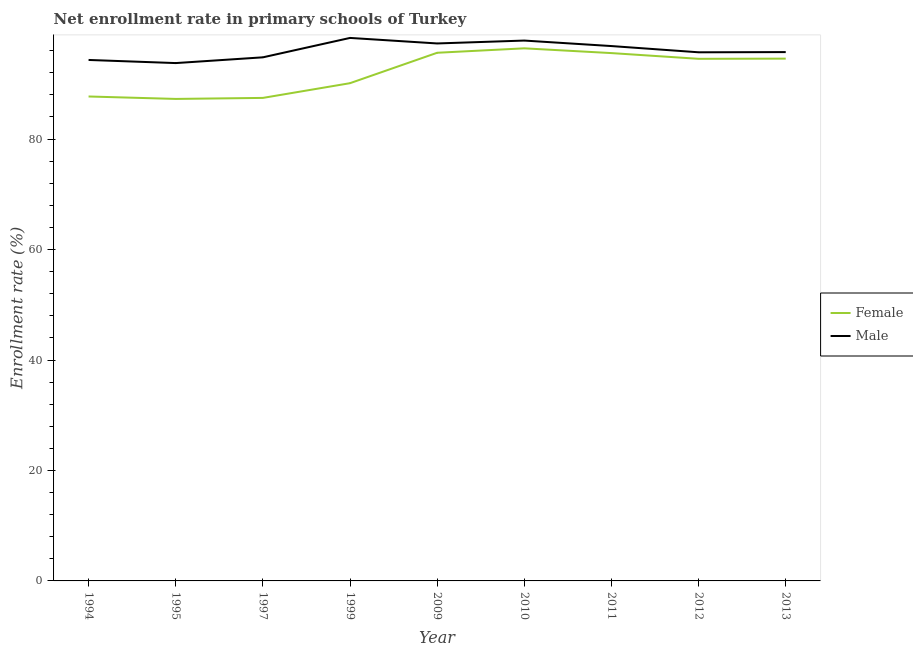Is the number of lines equal to the number of legend labels?
Your response must be concise. Yes. What is the enrollment rate of female students in 1997?
Offer a terse response. 87.46. Across all years, what is the maximum enrollment rate of male students?
Offer a terse response. 98.32. Across all years, what is the minimum enrollment rate of female students?
Provide a short and direct response. 87.27. In which year was the enrollment rate of female students minimum?
Give a very brief answer. 1995. What is the total enrollment rate of female students in the graph?
Offer a very short reply. 829.29. What is the difference between the enrollment rate of male students in 1994 and that in 2009?
Offer a very short reply. -2.99. What is the difference between the enrollment rate of male students in 2009 and the enrollment rate of female students in 1997?
Offer a very short reply. 9.86. What is the average enrollment rate of male students per year?
Your answer should be compact. 96.07. In the year 1997, what is the difference between the enrollment rate of male students and enrollment rate of female students?
Give a very brief answer. 7.35. In how many years, is the enrollment rate of female students greater than 52 %?
Your answer should be very brief. 9. What is the ratio of the enrollment rate of male students in 2010 to that in 2013?
Offer a terse response. 1.02. Is the difference between the enrollment rate of female students in 1995 and 1997 greater than the difference between the enrollment rate of male students in 1995 and 1997?
Your answer should be compact. Yes. What is the difference between the highest and the second highest enrollment rate of female students?
Your answer should be very brief. 0.8. What is the difference between the highest and the lowest enrollment rate of male students?
Ensure brevity in your answer.  4.56. In how many years, is the enrollment rate of male students greater than the average enrollment rate of male students taken over all years?
Your answer should be compact. 4. Is the sum of the enrollment rate of male students in 1994 and 2009 greater than the maximum enrollment rate of female students across all years?
Offer a very short reply. Yes. Is the enrollment rate of female students strictly less than the enrollment rate of male students over the years?
Your answer should be very brief. Yes. How many years are there in the graph?
Give a very brief answer. 9. What is the difference between two consecutive major ticks on the Y-axis?
Ensure brevity in your answer.  20. Are the values on the major ticks of Y-axis written in scientific E-notation?
Give a very brief answer. No. Does the graph contain any zero values?
Your answer should be very brief. No. Does the graph contain grids?
Provide a short and direct response. No. Where does the legend appear in the graph?
Your answer should be compact. Center right. How many legend labels are there?
Provide a succinct answer. 2. What is the title of the graph?
Provide a short and direct response. Net enrollment rate in primary schools of Turkey. Does "From Government" appear as one of the legend labels in the graph?
Provide a succinct answer. No. What is the label or title of the X-axis?
Your response must be concise. Year. What is the label or title of the Y-axis?
Provide a succinct answer. Enrollment rate (%). What is the Enrollment rate (%) in Female in 1994?
Provide a short and direct response. 87.71. What is the Enrollment rate (%) in Male in 1994?
Your response must be concise. 94.33. What is the Enrollment rate (%) in Female in 1995?
Give a very brief answer. 87.27. What is the Enrollment rate (%) in Male in 1995?
Provide a succinct answer. 93.76. What is the Enrollment rate (%) in Female in 1997?
Provide a succinct answer. 87.46. What is the Enrollment rate (%) of Male in 1997?
Provide a short and direct response. 94.8. What is the Enrollment rate (%) in Female in 1999?
Keep it short and to the point. 90.12. What is the Enrollment rate (%) of Male in 1999?
Make the answer very short. 98.32. What is the Enrollment rate (%) of Female in 2009?
Your response must be concise. 95.63. What is the Enrollment rate (%) in Male in 2009?
Your answer should be very brief. 97.31. What is the Enrollment rate (%) of Female in 2010?
Ensure brevity in your answer.  96.43. What is the Enrollment rate (%) in Male in 2010?
Offer a terse response. 97.84. What is the Enrollment rate (%) in Female in 2011?
Make the answer very short. 95.57. What is the Enrollment rate (%) in Male in 2011?
Your response must be concise. 96.84. What is the Enrollment rate (%) of Female in 2012?
Provide a short and direct response. 94.53. What is the Enrollment rate (%) of Male in 2012?
Provide a succinct answer. 95.71. What is the Enrollment rate (%) in Female in 2013?
Ensure brevity in your answer.  94.57. What is the Enrollment rate (%) of Male in 2013?
Your answer should be very brief. 95.75. Across all years, what is the maximum Enrollment rate (%) in Female?
Offer a terse response. 96.43. Across all years, what is the maximum Enrollment rate (%) of Male?
Your response must be concise. 98.32. Across all years, what is the minimum Enrollment rate (%) of Female?
Your answer should be compact. 87.27. Across all years, what is the minimum Enrollment rate (%) in Male?
Your answer should be compact. 93.76. What is the total Enrollment rate (%) of Female in the graph?
Your response must be concise. 829.29. What is the total Enrollment rate (%) of Male in the graph?
Provide a short and direct response. 864.66. What is the difference between the Enrollment rate (%) in Female in 1994 and that in 1995?
Offer a very short reply. 0.44. What is the difference between the Enrollment rate (%) in Male in 1994 and that in 1995?
Offer a very short reply. 0.57. What is the difference between the Enrollment rate (%) in Female in 1994 and that in 1997?
Your answer should be compact. 0.26. What is the difference between the Enrollment rate (%) in Male in 1994 and that in 1997?
Keep it short and to the point. -0.48. What is the difference between the Enrollment rate (%) of Female in 1994 and that in 1999?
Your answer should be very brief. -2.41. What is the difference between the Enrollment rate (%) in Male in 1994 and that in 1999?
Keep it short and to the point. -3.99. What is the difference between the Enrollment rate (%) of Female in 1994 and that in 2009?
Make the answer very short. -7.91. What is the difference between the Enrollment rate (%) in Male in 1994 and that in 2009?
Your response must be concise. -2.99. What is the difference between the Enrollment rate (%) in Female in 1994 and that in 2010?
Offer a terse response. -8.72. What is the difference between the Enrollment rate (%) in Male in 1994 and that in 2010?
Your answer should be compact. -3.51. What is the difference between the Enrollment rate (%) in Female in 1994 and that in 2011?
Provide a succinct answer. -7.86. What is the difference between the Enrollment rate (%) of Male in 1994 and that in 2011?
Provide a succinct answer. -2.52. What is the difference between the Enrollment rate (%) of Female in 1994 and that in 2012?
Keep it short and to the point. -6.82. What is the difference between the Enrollment rate (%) of Male in 1994 and that in 2012?
Your response must be concise. -1.39. What is the difference between the Enrollment rate (%) in Female in 1994 and that in 2013?
Keep it short and to the point. -6.85. What is the difference between the Enrollment rate (%) in Male in 1994 and that in 2013?
Keep it short and to the point. -1.42. What is the difference between the Enrollment rate (%) in Female in 1995 and that in 1997?
Keep it short and to the point. -0.18. What is the difference between the Enrollment rate (%) of Male in 1995 and that in 1997?
Make the answer very short. -1.04. What is the difference between the Enrollment rate (%) in Female in 1995 and that in 1999?
Make the answer very short. -2.85. What is the difference between the Enrollment rate (%) in Male in 1995 and that in 1999?
Provide a short and direct response. -4.56. What is the difference between the Enrollment rate (%) of Female in 1995 and that in 2009?
Make the answer very short. -8.36. What is the difference between the Enrollment rate (%) in Male in 1995 and that in 2009?
Provide a succinct answer. -3.55. What is the difference between the Enrollment rate (%) of Female in 1995 and that in 2010?
Give a very brief answer. -9.16. What is the difference between the Enrollment rate (%) in Male in 1995 and that in 2010?
Keep it short and to the point. -4.08. What is the difference between the Enrollment rate (%) of Female in 1995 and that in 2011?
Offer a terse response. -8.3. What is the difference between the Enrollment rate (%) in Male in 1995 and that in 2011?
Offer a terse response. -3.08. What is the difference between the Enrollment rate (%) of Female in 1995 and that in 2012?
Keep it short and to the point. -7.26. What is the difference between the Enrollment rate (%) of Male in 1995 and that in 2012?
Your answer should be very brief. -1.95. What is the difference between the Enrollment rate (%) of Female in 1995 and that in 2013?
Offer a very short reply. -7.3. What is the difference between the Enrollment rate (%) of Male in 1995 and that in 2013?
Your answer should be compact. -1.99. What is the difference between the Enrollment rate (%) of Female in 1997 and that in 1999?
Your response must be concise. -2.66. What is the difference between the Enrollment rate (%) of Male in 1997 and that in 1999?
Your answer should be very brief. -3.51. What is the difference between the Enrollment rate (%) of Female in 1997 and that in 2009?
Keep it short and to the point. -8.17. What is the difference between the Enrollment rate (%) of Male in 1997 and that in 2009?
Provide a succinct answer. -2.51. What is the difference between the Enrollment rate (%) of Female in 1997 and that in 2010?
Offer a very short reply. -8.97. What is the difference between the Enrollment rate (%) in Male in 1997 and that in 2010?
Offer a terse response. -3.04. What is the difference between the Enrollment rate (%) of Female in 1997 and that in 2011?
Provide a short and direct response. -8.11. What is the difference between the Enrollment rate (%) in Male in 1997 and that in 2011?
Your response must be concise. -2.04. What is the difference between the Enrollment rate (%) of Female in 1997 and that in 2012?
Offer a very short reply. -7.08. What is the difference between the Enrollment rate (%) of Male in 1997 and that in 2012?
Give a very brief answer. -0.91. What is the difference between the Enrollment rate (%) in Female in 1997 and that in 2013?
Your response must be concise. -7.11. What is the difference between the Enrollment rate (%) in Male in 1997 and that in 2013?
Keep it short and to the point. -0.95. What is the difference between the Enrollment rate (%) of Female in 1999 and that in 2009?
Your response must be concise. -5.51. What is the difference between the Enrollment rate (%) in Male in 1999 and that in 2009?
Provide a succinct answer. 1. What is the difference between the Enrollment rate (%) in Female in 1999 and that in 2010?
Give a very brief answer. -6.31. What is the difference between the Enrollment rate (%) of Male in 1999 and that in 2010?
Offer a very short reply. 0.48. What is the difference between the Enrollment rate (%) of Female in 1999 and that in 2011?
Offer a very short reply. -5.45. What is the difference between the Enrollment rate (%) in Male in 1999 and that in 2011?
Keep it short and to the point. 1.47. What is the difference between the Enrollment rate (%) of Female in 1999 and that in 2012?
Keep it short and to the point. -4.41. What is the difference between the Enrollment rate (%) of Male in 1999 and that in 2012?
Provide a short and direct response. 2.6. What is the difference between the Enrollment rate (%) of Female in 1999 and that in 2013?
Your answer should be very brief. -4.45. What is the difference between the Enrollment rate (%) in Male in 1999 and that in 2013?
Keep it short and to the point. 2.57. What is the difference between the Enrollment rate (%) in Female in 2009 and that in 2010?
Your answer should be compact. -0.8. What is the difference between the Enrollment rate (%) of Male in 2009 and that in 2010?
Provide a short and direct response. -0.53. What is the difference between the Enrollment rate (%) in Female in 2009 and that in 2011?
Make the answer very short. 0.06. What is the difference between the Enrollment rate (%) in Male in 2009 and that in 2011?
Provide a succinct answer. 0.47. What is the difference between the Enrollment rate (%) in Female in 2009 and that in 2012?
Offer a very short reply. 1.1. What is the difference between the Enrollment rate (%) in Male in 2009 and that in 2012?
Keep it short and to the point. 1.6. What is the difference between the Enrollment rate (%) in Female in 2009 and that in 2013?
Your response must be concise. 1.06. What is the difference between the Enrollment rate (%) of Male in 2009 and that in 2013?
Make the answer very short. 1.56. What is the difference between the Enrollment rate (%) of Female in 2010 and that in 2011?
Give a very brief answer. 0.86. What is the difference between the Enrollment rate (%) of Male in 2010 and that in 2011?
Ensure brevity in your answer.  1. What is the difference between the Enrollment rate (%) of Female in 2010 and that in 2012?
Offer a very short reply. 1.9. What is the difference between the Enrollment rate (%) of Male in 2010 and that in 2012?
Your response must be concise. 2.12. What is the difference between the Enrollment rate (%) of Female in 2010 and that in 2013?
Provide a succinct answer. 1.86. What is the difference between the Enrollment rate (%) in Male in 2010 and that in 2013?
Your response must be concise. 2.09. What is the difference between the Enrollment rate (%) of Female in 2011 and that in 2012?
Offer a terse response. 1.04. What is the difference between the Enrollment rate (%) in Male in 2011 and that in 2012?
Offer a terse response. 1.13. What is the difference between the Enrollment rate (%) in Female in 2011 and that in 2013?
Give a very brief answer. 1. What is the difference between the Enrollment rate (%) in Male in 2011 and that in 2013?
Keep it short and to the point. 1.09. What is the difference between the Enrollment rate (%) of Female in 2012 and that in 2013?
Provide a short and direct response. -0.03. What is the difference between the Enrollment rate (%) in Male in 2012 and that in 2013?
Provide a short and direct response. -0.03. What is the difference between the Enrollment rate (%) in Female in 1994 and the Enrollment rate (%) in Male in 1995?
Ensure brevity in your answer.  -6.05. What is the difference between the Enrollment rate (%) of Female in 1994 and the Enrollment rate (%) of Male in 1997?
Offer a very short reply. -7.09. What is the difference between the Enrollment rate (%) in Female in 1994 and the Enrollment rate (%) in Male in 1999?
Your answer should be very brief. -10.6. What is the difference between the Enrollment rate (%) in Female in 1994 and the Enrollment rate (%) in Male in 2009?
Provide a succinct answer. -9.6. What is the difference between the Enrollment rate (%) of Female in 1994 and the Enrollment rate (%) of Male in 2010?
Make the answer very short. -10.13. What is the difference between the Enrollment rate (%) of Female in 1994 and the Enrollment rate (%) of Male in 2011?
Offer a terse response. -9.13. What is the difference between the Enrollment rate (%) in Female in 1994 and the Enrollment rate (%) in Male in 2012?
Make the answer very short. -8. What is the difference between the Enrollment rate (%) of Female in 1994 and the Enrollment rate (%) of Male in 2013?
Provide a succinct answer. -8.04. What is the difference between the Enrollment rate (%) in Female in 1995 and the Enrollment rate (%) in Male in 1997?
Your answer should be very brief. -7.53. What is the difference between the Enrollment rate (%) of Female in 1995 and the Enrollment rate (%) of Male in 1999?
Your answer should be very brief. -11.04. What is the difference between the Enrollment rate (%) in Female in 1995 and the Enrollment rate (%) in Male in 2009?
Your answer should be compact. -10.04. What is the difference between the Enrollment rate (%) of Female in 1995 and the Enrollment rate (%) of Male in 2010?
Offer a very short reply. -10.57. What is the difference between the Enrollment rate (%) in Female in 1995 and the Enrollment rate (%) in Male in 2011?
Your answer should be compact. -9.57. What is the difference between the Enrollment rate (%) in Female in 1995 and the Enrollment rate (%) in Male in 2012?
Your answer should be very brief. -8.44. What is the difference between the Enrollment rate (%) of Female in 1995 and the Enrollment rate (%) of Male in 2013?
Provide a succinct answer. -8.48. What is the difference between the Enrollment rate (%) in Female in 1997 and the Enrollment rate (%) in Male in 1999?
Offer a very short reply. -10.86. What is the difference between the Enrollment rate (%) of Female in 1997 and the Enrollment rate (%) of Male in 2009?
Provide a short and direct response. -9.86. What is the difference between the Enrollment rate (%) of Female in 1997 and the Enrollment rate (%) of Male in 2010?
Provide a succinct answer. -10.38. What is the difference between the Enrollment rate (%) of Female in 1997 and the Enrollment rate (%) of Male in 2011?
Your response must be concise. -9.39. What is the difference between the Enrollment rate (%) of Female in 1997 and the Enrollment rate (%) of Male in 2012?
Give a very brief answer. -8.26. What is the difference between the Enrollment rate (%) of Female in 1997 and the Enrollment rate (%) of Male in 2013?
Give a very brief answer. -8.29. What is the difference between the Enrollment rate (%) in Female in 1999 and the Enrollment rate (%) in Male in 2009?
Keep it short and to the point. -7.19. What is the difference between the Enrollment rate (%) of Female in 1999 and the Enrollment rate (%) of Male in 2010?
Provide a short and direct response. -7.72. What is the difference between the Enrollment rate (%) of Female in 1999 and the Enrollment rate (%) of Male in 2011?
Your answer should be very brief. -6.72. What is the difference between the Enrollment rate (%) of Female in 1999 and the Enrollment rate (%) of Male in 2012?
Ensure brevity in your answer.  -5.59. What is the difference between the Enrollment rate (%) of Female in 1999 and the Enrollment rate (%) of Male in 2013?
Your answer should be very brief. -5.63. What is the difference between the Enrollment rate (%) of Female in 2009 and the Enrollment rate (%) of Male in 2010?
Your answer should be very brief. -2.21. What is the difference between the Enrollment rate (%) in Female in 2009 and the Enrollment rate (%) in Male in 2011?
Make the answer very short. -1.21. What is the difference between the Enrollment rate (%) of Female in 2009 and the Enrollment rate (%) of Male in 2012?
Provide a succinct answer. -0.09. What is the difference between the Enrollment rate (%) in Female in 2009 and the Enrollment rate (%) in Male in 2013?
Provide a succinct answer. -0.12. What is the difference between the Enrollment rate (%) in Female in 2010 and the Enrollment rate (%) in Male in 2011?
Your answer should be compact. -0.41. What is the difference between the Enrollment rate (%) of Female in 2010 and the Enrollment rate (%) of Male in 2012?
Your response must be concise. 0.72. What is the difference between the Enrollment rate (%) in Female in 2010 and the Enrollment rate (%) in Male in 2013?
Make the answer very short. 0.68. What is the difference between the Enrollment rate (%) in Female in 2011 and the Enrollment rate (%) in Male in 2012?
Offer a very short reply. -0.14. What is the difference between the Enrollment rate (%) of Female in 2011 and the Enrollment rate (%) of Male in 2013?
Provide a succinct answer. -0.18. What is the difference between the Enrollment rate (%) of Female in 2012 and the Enrollment rate (%) of Male in 2013?
Give a very brief answer. -1.22. What is the average Enrollment rate (%) in Female per year?
Provide a succinct answer. 92.14. What is the average Enrollment rate (%) in Male per year?
Provide a short and direct response. 96.07. In the year 1994, what is the difference between the Enrollment rate (%) of Female and Enrollment rate (%) of Male?
Ensure brevity in your answer.  -6.61. In the year 1995, what is the difference between the Enrollment rate (%) in Female and Enrollment rate (%) in Male?
Your answer should be compact. -6.49. In the year 1997, what is the difference between the Enrollment rate (%) of Female and Enrollment rate (%) of Male?
Provide a succinct answer. -7.35. In the year 1999, what is the difference between the Enrollment rate (%) of Female and Enrollment rate (%) of Male?
Give a very brief answer. -8.19. In the year 2009, what is the difference between the Enrollment rate (%) of Female and Enrollment rate (%) of Male?
Provide a short and direct response. -1.69. In the year 2010, what is the difference between the Enrollment rate (%) of Female and Enrollment rate (%) of Male?
Your answer should be very brief. -1.41. In the year 2011, what is the difference between the Enrollment rate (%) of Female and Enrollment rate (%) of Male?
Provide a succinct answer. -1.27. In the year 2012, what is the difference between the Enrollment rate (%) of Female and Enrollment rate (%) of Male?
Offer a very short reply. -1.18. In the year 2013, what is the difference between the Enrollment rate (%) of Female and Enrollment rate (%) of Male?
Your answer should be very brief. -1.18. What is the ratio of the Enrollment rate (%) of Female in 1994 to that in 1997?
Give a very brief answer. 1. What is the ratio of the Enrollment rate (%) in Male in 1994 to that in 1997?
Provide a succinct answer. 0.99. What is the ratio of the Enrollment rate (%) of Female in 1994 to that in 1999?
Your response must be concise. 0.97. What is the ratio of the Enrollment rate (%) in Male in 1994 to that in 1999?
Ensure brevity in your answer.  0.96. What is the ratio of the Enrollment rate (%) of Female in 1994 to that in 2009?
Your response must be concise. 0.92. What is the ratio of the Enrollment rate (%) in Male in 1994 to that in 2009?
Provide a short and direct response. 0.97. What is the ratio of the Enrollment rate (%) in Female in 1994 to that in 2010?
Provide a short and direct response. 0.91. What is the ratio of the Enrollment rate (%) of Male in 1994 to that in 2010?
Provide a short and direct response. 0.96. What is the ratio of the Enrollment rate (%) of Female in 1994 to that in 2011?
Make the answer very short. 0.92. What is the ratio of the Enrollment rate (%) of Male in 1994 to that in 2011?
Provide a short and direct response. 0.97. What is the ratio of the Enrollment rate (%) in Female in 1994 to that in 2012?
Your answer should be very brief. 0.93. What is the ratio of the Enrollment rate (%) in Male in 1994 to that in 2012?
Ensure brevity in your answer.  0.99. What is the ratio of the Enrollment rate (%) in Female in 1994 to that in 2013?
Give a very brief answer. 0.93. What is the ratio of the Enrollment rate (%) in Male in 1994 to that in 2013?
Your answer should be very brief. 0.99. What is the ratio of the Enrollment rate (%) of Female in 1995 to that in 1999?
Offer a very short reply. 0.97. What is the ratio of the Enrollment rate (%) in Male in 1995 to that in 1999?
Your response must be concise. 0.95. What is the ratio of the Enrollment rate (%) of Female in 1995 to that in 2009?
Give a very brief answer. 0.91. What is the ratio of the Enrollment rate (%) in Male in 1995 to that in 2009?
Your answer should be compact. 0.96. What is the ratio of the Enrollment rate (%) of Female in 1995 to that in 2010?
Offer a terse response. 0.91. What is the ratio of the Enrollment rate (%) of Male in 1995 to that in 2010?
Your answer should be very brief. 0.96. What is the ratio of the Enrollment rate (%) of Female in 1995 to that in 2011?
Provide a succinct answer. 0.91. What is the ratio of the Enrollment rate (%) in Male in 1995 to that in 2011?
Keep it short and to the point. 0.97. What is the ratio of the Enrollment rate (%) in Female in 1995 to that in 2012?
Your answer should be very brief. 0.92. What is the ratio of the Enrollment rate (%) of Male in 1995 to that in 2012?
Offer a terse response. 0.98. What is the ratio of the Enrollment rate (%) of Female in 1995 to that in 2013?
Your answer should be compact. 0.92. What is the ratio of the Enrollment rate (%) in Male in 1995 to that in 2013?
Provide a short and direct response. 0.98. What is the ratio of the Enrollment rate (%) of Female in 1997 to that in 1999?
Offer a terse response. 0.97. What is the ratio of the Enrollment rate (%) in Male in 1997 to that in 1999?
Your answer should be very brief. 0.96. What is the ratio of the Enrollment rate (%) in Female in 1997 to that in 2009?
Offer a terse response. 0.91. What is the ratio of the Enrollment rate (%) of Male in 1997 to that in 2009?
Make the answer very short. 0.97. What is the ratio of the Enrollment rate (%) in Female in 1997 to that in 2010?
Offer a terse response. 0.91. What is the ratio of the Enrollment rate (%) of Male in 1997 to that in 2010?
Offer a very short reply. 0.97. What is the ratio of the Enrollment rate (%) in Female in 1997 to that in 2011?
Provide a succinct answer. 0.92. What is the ratio of the Enrollment rate (%) in Male in 1997 to that in 2011?
Ensure brevity in your answer.  0.98. What is the ratio of the Enrollment rate (%) of Female in 1997 to that in 2012?
Ensure brevity in your answer.  0.93. What is the ratio of the Enrollment rate (%) of Female in 1997 to that in 2013?
Your response must be concise. 0.92. What is the ratio of the Enrollment rate (%) in Female in 1999 to that in 2009?
Your answer should be compact. 0.94. What is the ratio of the Enrollment rate (%) in Male in 1999 to that in 2009?
Your response must be concise. 1.01. What is the ratio of the Enrollment rate (%) of Female in 1999 to that in 2010?
Offer a very short reply. 0.93. What is the ratio of the Enrollment rate (%) of Female in 1999 to that in 2011?
Offer a terse response. 0.94. What is the ratio of the Enrollment rate (%) of Male in 1999 to that in 2011?
Your answer should be very brief. 1.02. What is the ratio of the Enrollment rate (%) of Female in 1999 to that in 2012?
Offer a very short reply. 0.95. What is the ratio of the Enrollment rate (%) of Male in 1999 to that in 2012?
Make the answer very short. 1.03. What is the ratio of the Enrollment rate (%) of Female in 1999 to that in 2013?
Provide a succinct answer. 0.95. What is the ratio of the Enrollment rate (%) in Male in 1999 to that in 2013?
Offer a very short reply. 1.03. What is the ratio of the Enrollment rate (%) in Female in 2009 to that in 2010?
Keep it short and to the point. 0.99. What is the ratio of the Enrollment rate (%) of Male in 2009 to that in 2011?
Ensure brevity in your answer.  1. What is the ratio of the Enrollment rate (%) in Female in 2009 to that in 2012?
Make the answer very short. 1.01. What is the ratio of the Enrollment rate (%) in Male in 2009 to that in 2012?
Ensure brevity in your answer.  1.02. What is the ratio of the Enrollment rate (%) in Female in 2009 to that in 2013?
Give a very brief answer. 1.01. What is the ratio of the Enrollment rate (%) of Male in 2009 to that in 2013?
Keep it short and to the point. 1.02. What is the ratio of the Enrollment rate (%) in Female in 2010 to that in 2011?
Ensure brevity in your answer.  1.01. What is the ratio of the Enrollment rate (%) in Male in 2010 to that in 2011?
Your response must be concise. 1.01. What is the ratio of the Enrollment rate (%) in Female in 2010 to that in 2012?
Your answer should be very brief. 1.02. What is the ratio of the Enrollment rate (%) of Male in 2010 to that in 2012?
Your answer should be compact. 1.02. What is the ratio of the Enrollment rate (%) in Female in 2010 to that in 2013?
Offer a terse response. 1.02. What is the ratio of the Enrollment rate (%) in Male in 2010 to that in 2013?
Your response must be concise. 1.02. What is the ratio of the Enrollment rate (%) in Male in 2011 to that in 2012?
Provide a succinct answer. 1.01. What is the ratio of the Enrollment rate (%) in Female in 2011 to that in 2013?
Provide a succinct answer. 1.01. What is the ratio of the Enrollment rate (%) of Male in 2011 to that in 2013?
Give a very brief answer. 1.01. What is the ratio of the Enrollment rate (%) of Male in 2012 to that in 2013?
Keep it short and to the point. 1. What is the difference between the highest and the second highest Enrollment rate (%) in Female?
Make the answer very short. 0.8. What is the difference between the highest and the second highest Enrollment rate (%) in Male?
Give a very brief answer. 0.48. What is the difference between the highest and the lowest Enrollment rate (%) of Female?
Your response must be concise. 9.16. What is the difference between the highest and the lowest Enrollment rate (%) in Male?
Your answer should be compact. 4.56. 